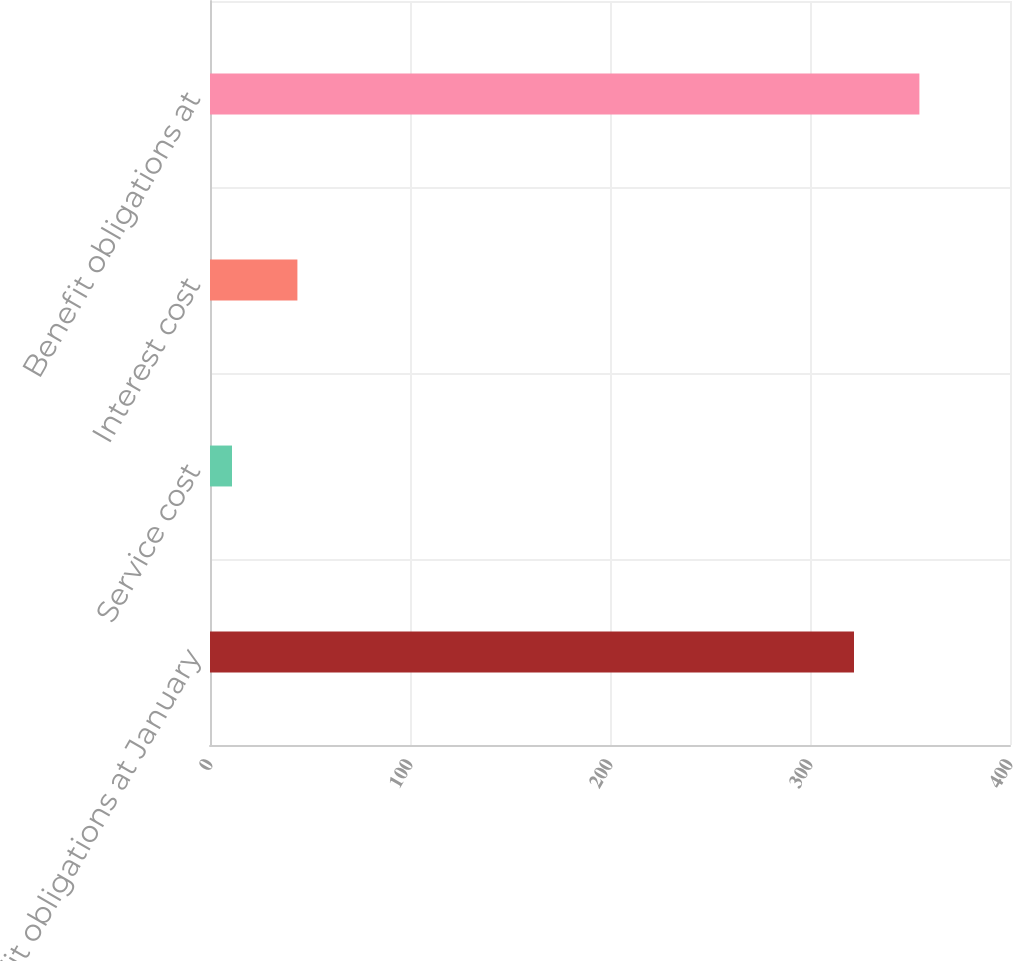Convert chart to OTSL. <chart><loc_0><loc_0><loc_500><loc_500><bar_chart><fcel>Benefit obligations at January<fcel>Service cost<fcel>Interest cost<fcel>Benefit obligations at<nl><fcel>322<fcel>11<fcel>43.7<fcel>354.7<nl></chart> 